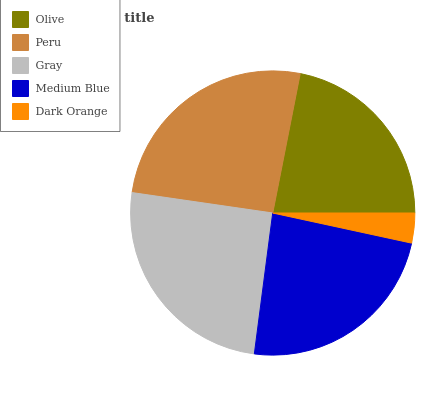Is Dark Orange the minimum?
Answer yes or no. Yes. Is Peru the maximum?
Answer yes or no. Yes. Is Gray the minimum?
Answer yes or no. No. Is Gray the maximum?
Answer yes or no. No. Is Peru greater than Gray?
Answer yes or no. Yes. Is Gray less than Peru?
Answer yes or no. Yes. Is Gray greater than Peru?
Answer yes or no. No. Is Peru less than Gray?
Answer yes or no. No. Is Medium Blue the high median?
Answer yes or no. Yes. Is Medium Blue the low median?
Answer yes or no. Yes. Is Olive the high median?
Answer yes or no. No. Is Dark Orange the low median?
Answer yes or no. No. 